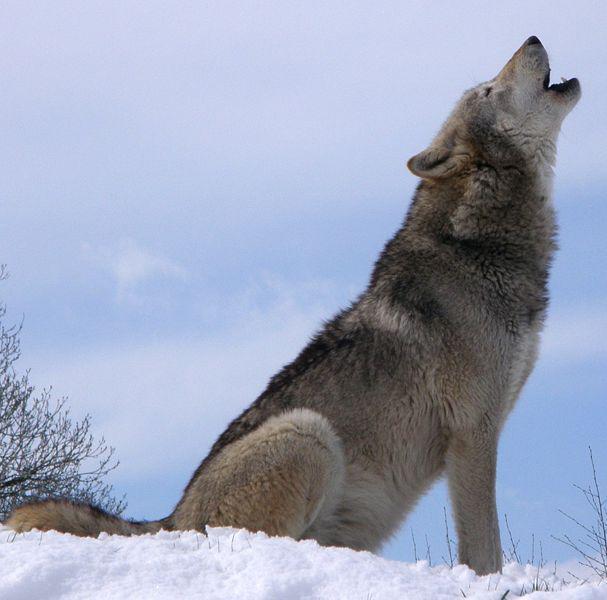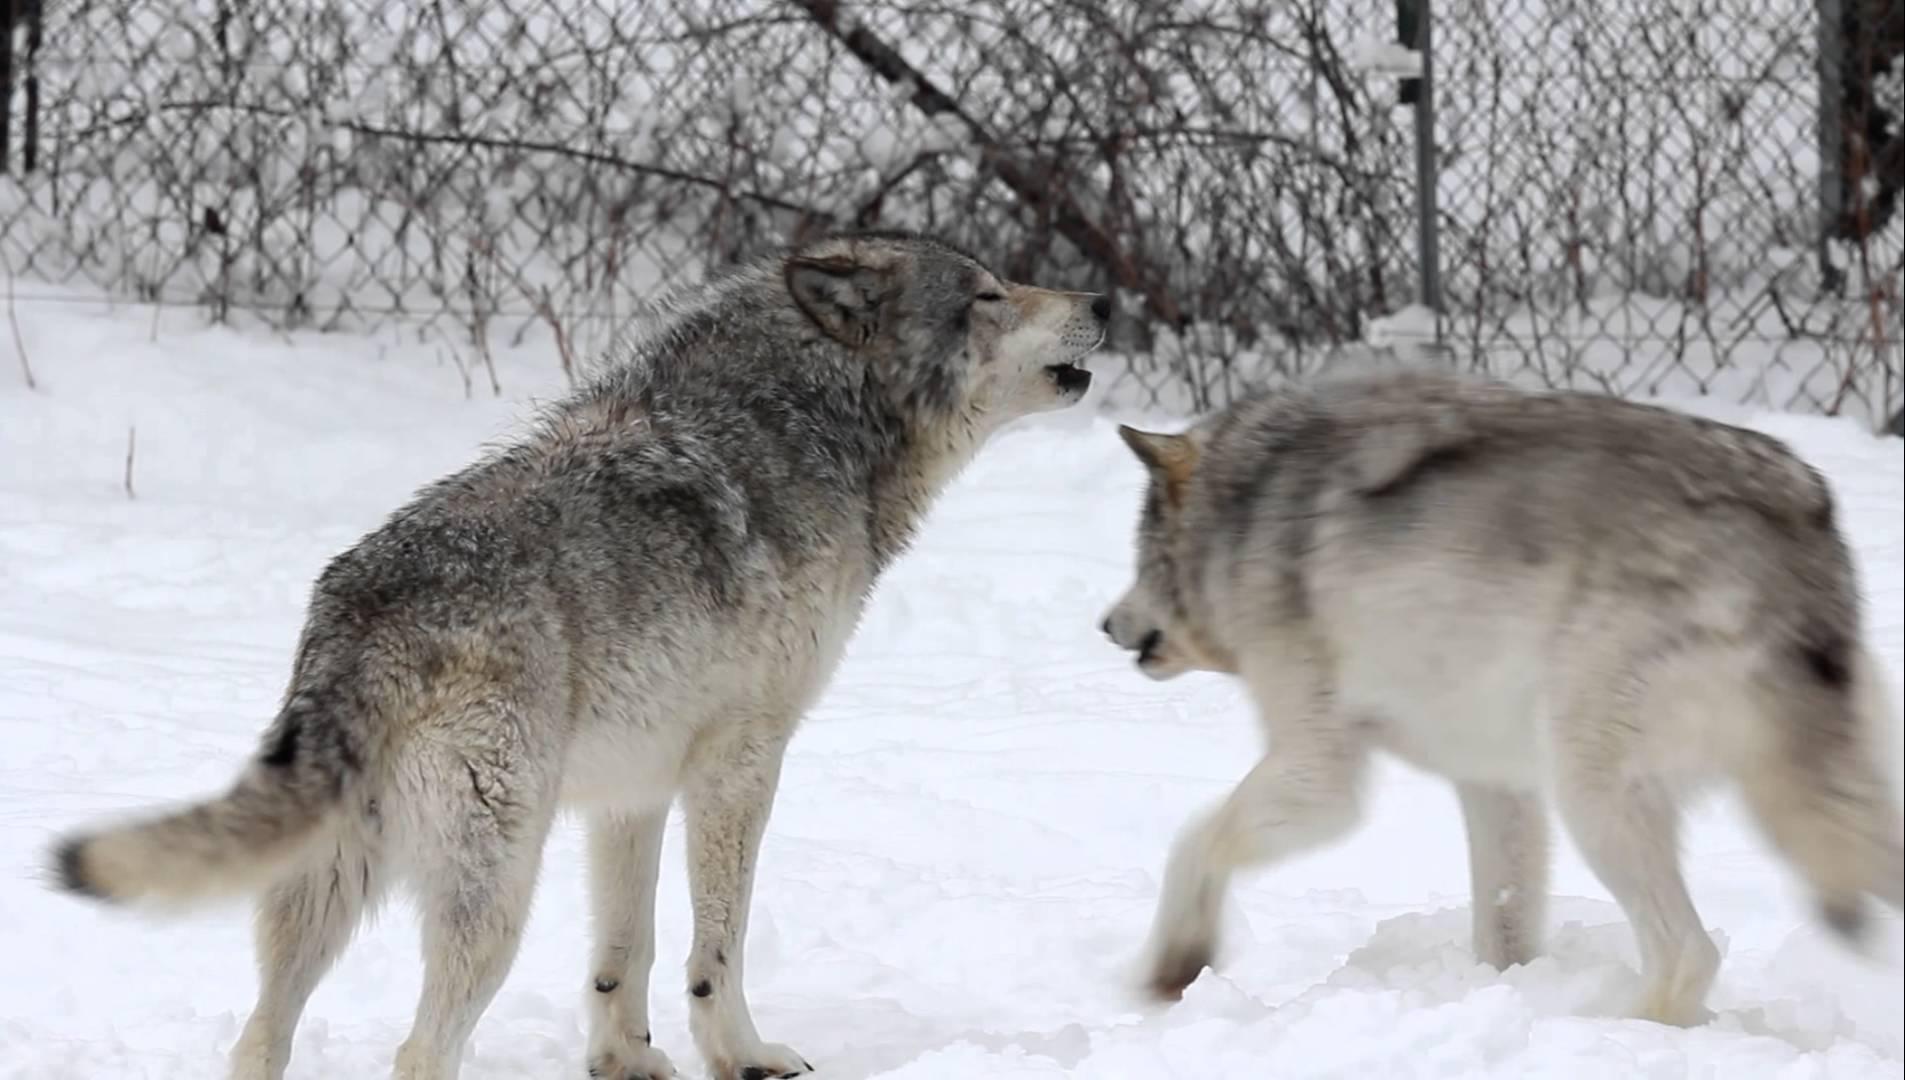The first image is the image on the left, the second image is the image on the right. Analyze the images presented: Is the assertion "There are only two dogs and both are howling at the sky." valid? Answer yes or no. No. 